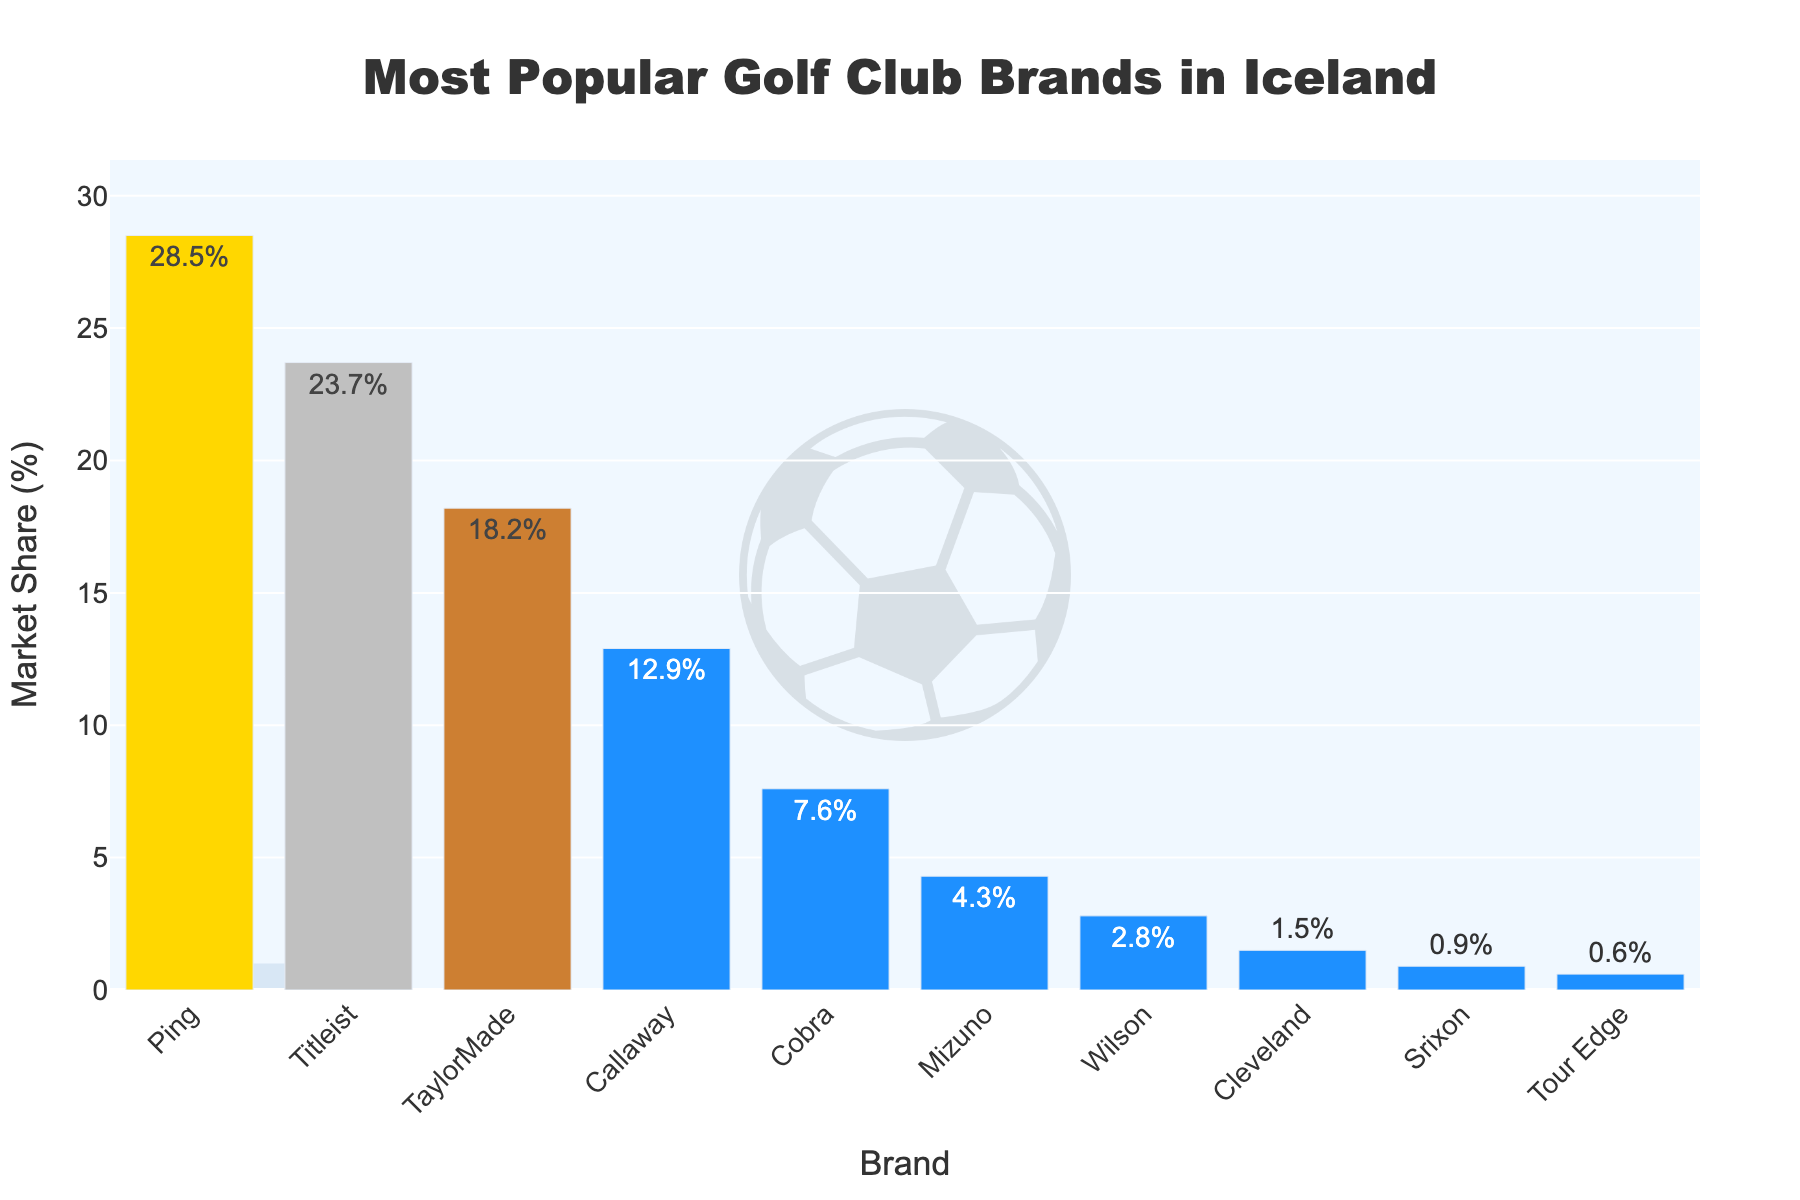What are the top three most popular golf club brands in Iceland? The three bars with the highest market share represent the most popular brands. These are Ping (28.5%), Titleist (23.7%), and TaylorMade (18.2%).
Answer: Ping, Titleist, TaylorMade What is the combined market share of Ping and Titleist? Add the market shares of Ping and Titleist: 28.5% + 23.7% = 52.2%.
Answer: 52.2% How much larger is Ping's market share compared to Callaway's? Subtract Callaway's market share from Ping's: 28.5% - 12.9% = 15.6%.
Answer: 15.6% Which brand has the smallest market share and what is it? The shortest bar in the chart represents the brand with the smallest market share, which is Tour Edge with 0.6%.
Answer: Tour Edge, 0.6% What is the total market share of all brands lower than Cobra? Sum the market shares of brands lower than Cobra: Mizuno (4.3%) + Wilson (2.8%) + Cleveland (1.5%) + Srixon (0.9%) + Tour Edge (0.6%) = 10.1%.
Answer: 10.1% Which brand ranks fourth in terms of market share? The fourth tallest bar in the chart represents Callaway with a market share of 12.9%.
Answer: Callaway Is the market share of TaylorMade more than double the market share of Wilson? Compare TaylorMade's market share (18.2%) and double Wilson's market share (2.8% * 2 = 5.6%). Since 18.2% is greater than 5.6%, TaylorMade's share is indeed more than double Wilson's.
Answer: Yes What is the market share difference between the third and fourth most popular brands? Subtract the market share of the fourth most popular brand (Callaway, 12.9%) from the third most popular brand (TaylorMade, 18.2%): 18.2% - 12.9% = 5.3%.
Answer: 5.3% What color is used to represent the top three brands in the chart? The figure uses gold for the first (Ping), silver for the second (Titleist), and bronze for the third (TaylorMade).
Answer: Gold, Silver, Bronze What is the average market share of the bottom three brands? Sum the market shares of the bottom three brands and divide by three: (Cleveland 1.5% + Srixon 0.9% + Tour Edge 0.6%) / 3 = 3.0% / 3 = 1.0%.
Answer: 1.0% 